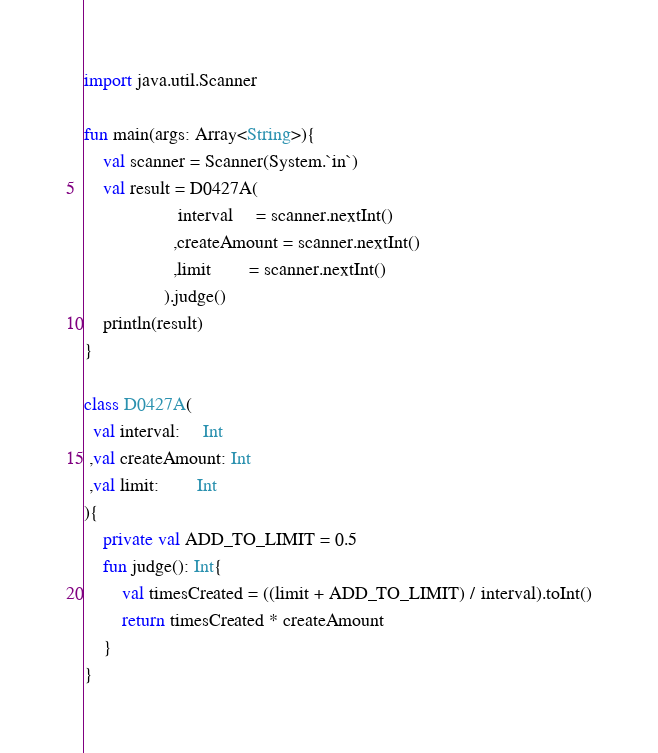Convert code to text. <code><loc_0><loc_0><loc_500><loc_500><_Kotlin_>import java.util.Scanner

fun main(args: Array<String>){
    val scanner = Scanner(System.`in`)
    val result = D0427A(
                    interval     = scanner.nextInt()
                   ,createAmount = scanner.nextInt()
                   ,limit        = scanner.nextInt()
                 ).judge()
    println(result)
}

class D0427A(
  val interval:     Int
 ,val createAmount: Int
 ,val limit:        Int
){
    private val ADD_TO_LIMIT = 0.5
    fun judge(): Int{
        val timesCreated = ((limit + ADD_TO_LIMIT) / interval).toInt()
        return timesCreated * createAmount
    }
}</code> 